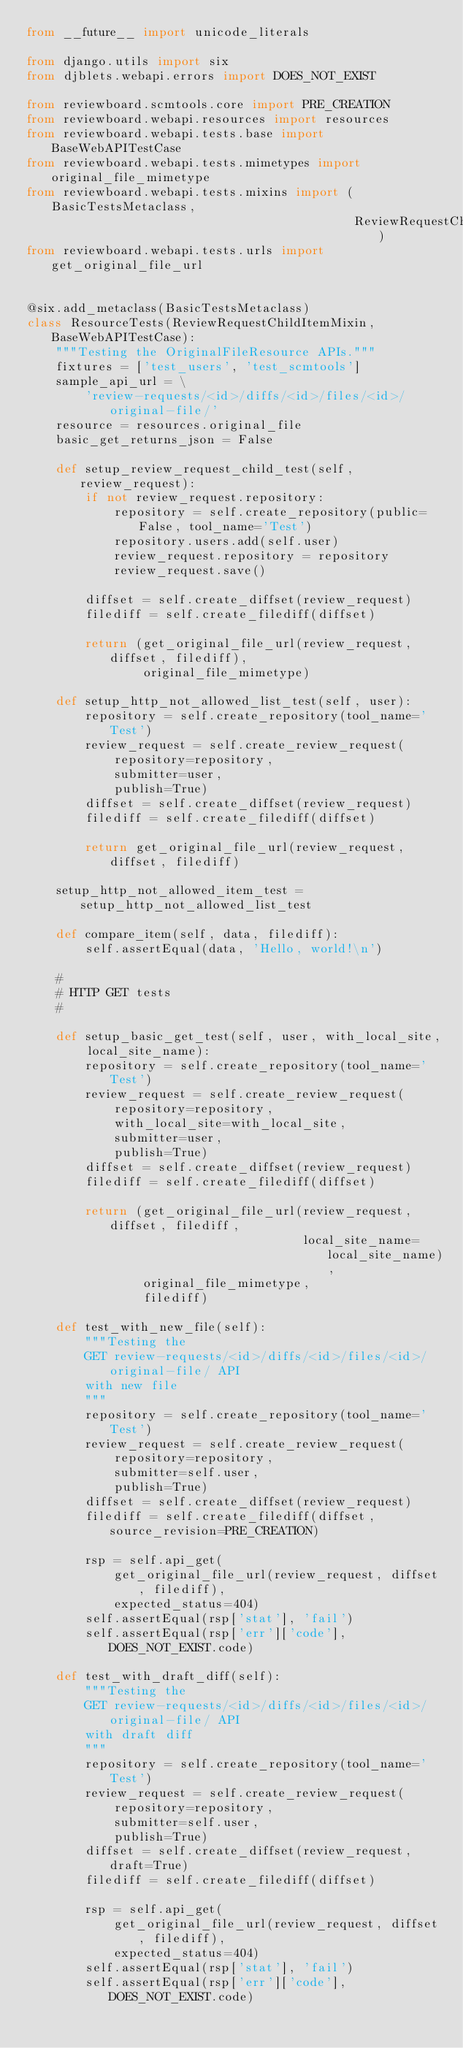<code> <loc_0><loc_0><loc_500><loc_500><_Python_>from __future__ import unicode_literals

from django.utils import six
from djblets.webapi.errors import DOES_NOT_EXIST

from reviewboard.scmtools.core import PRE_CREATION
from reviewboard.webapi.resources import resources
from reviewboard.webapi.tests.base import BaseWebAPITestCase
from reviewboard.webapi.tests.mimetypes import original_file_mimetype
from reviewboard.webapi.tests.mixins import (BasicTestsMetaclass,
                                             ReviewRequestChildItemMixin)
from reviewboard.webapi.tests.urls import get_original_file_url


@six.add_metaclass(BasicTestsMetaclass)
class ResourceTests(ReviewRequestChildItemMixin, BaseWebAPITestCase):
    """Testing the OriginalFileResource APIs."""
    fixtures = ['test_users', 'test_scmtools']
    sample_api_url = \
        'review-requests/<id>/diffs/<id>/files/<id>/original-file/'
    resource = resources.original_file
    basic_get_returns_json = False

    def setup_review_request_child_test(self, review_request):
        if not review_request.repository:
            repository = self.create_repository(public=False, tool_name='Test')
            repository.users.add(self.user)
            review_request.repository = repository
            review_request.save()

        diffset = self.create_diffset(review_request)
        filediff = self.create_filediff(diffset)

        return (get_original_file_url(review_request, diffset, filediff),
                original_file_mimetype)

    def setup_http_not_allowed_list_test(self, user):
        repository = self.create_repository(tool_name='Test')
        review_request = self.create_review_request(
            repository=repository,
            submitter=user,
            publish=True)
        diffset = self.create_diffset(review_request)
        filediff = self.create_filediff(diffset)

        return get_original_file_url(review_request, diffset, filediff)

    setup_http_not_allowed_item_test = setup_http_not_allowed_list_test

    def compare_item(self, data, filediff):
        self.assertEqual(data, 'Hello, world!\n')

    #
    # HTTP GET tests
    #

    def setup_basic_get_test(self, user, with_local_site, local_site_name):
        repository = self.create_repository(tool_name='Test')
        review_request = self.create_review_request(
            repository=repository,
            with_local_site=with_local_site,
            submitter=user,
            publish=True)
        diffset = self.create_diffset(review_request)
        filediff = self.create_filediff(diffset)

        return (get_original_file_url(review_request, diffset, filediff,
                                      local_site_name=local_site_name),
                original_file_mimetype,
                filediff)

    def test_with_new_file(self):
        """Testing the
        GET review-requests/<id>/diffs/<id>/files/<id>/original-file/ API
        with new file
        """
        repository = self.create_repository(tool_name='Test')
        review_request = self.create_review_request(
            repository=repository,
            submitter=self.user,
            publish=True)
        diffset = self.create_diffset(review_request)
        filediff = self.create_filediff(diffset, source_revision=PRE_CREATION)

        rsp = self.api_get(
            get_original_file_url(review_request, diffset, filediff),
            expected_status=404)
        self.assertEqual(rsp['stat'], 'fail')
        self.assertEqual(rsp['err']['code'], DOES_NOT_EXIST.code)

    def test_with_draft_diff(self):
        """Testing the
        GET review-requests/<id>/diffs/<id>/files/<id>/original-file/ API
        with draft diff
        """
        repository = self.create_repository(tool_name='Test')
        review_request = self.create_review_request(
            repository=repository,
            submitter=self.user,
            publish=True)
        diffset = self.create_diffset(review_request, draft=True)
        filediff = self.create_filediff(diffset)

        rsp = self.api_get(
            get_original_file_url(review_request, diffset, filediff),
            expected_status=404)
        self.assertEqual(rsp['stat'], 'fail')
        self.assertEqual(rsp['err']['code'], DOES_NOT_EXIST.code)
</code> 